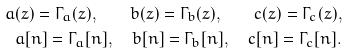Convert formula to latex. <formula><loc_0><loc_0><loc_500><loc_500>a ( z ) = \Gamma _ { a } ( z ) , \quad b ( z ) = \Gamma _ { b } ( z ) , \quad c ( z ) = \Gamma _ { c } ( z ) , \\ a [ n ] = \Gamma _ { a } [ n ] , \quad b [ n ] = \Gamma _ { b } [ n ] , \quad c [ n ] = \Gamma _ { c } [ n ] .</formula> 